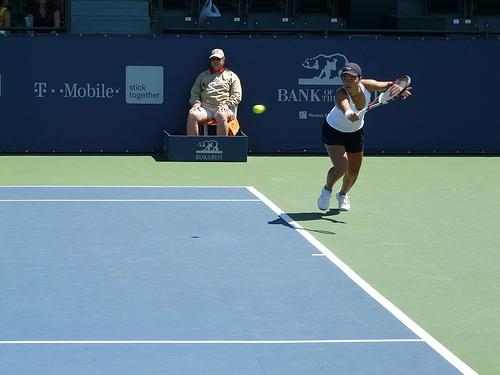Describe the most prominent features of the image in a concise manner. Woman playing tennis wearing a blue hat, white shoes, white top, and black shorts, with distinct shadows on the ground. Write a sentence describing the environment and ambiance of the tennis game shown in the image. The tennis game setting features a well-maintained court, clear blue and green sections, with keen spectators and a man sitting in a judging box. Explain the different court sections and colors in the image. The tennis court features a blue playing area with a white dividing line, and a green out-of-bounds section. Write a sentence describing the scene in the image, focusing on the main character and their action. A female tennis player is striking a green tennis ball in the air while a man observes from a chair on a colorful blue and green court. Provide a description of the individuals featured in the image and their roles. The image shows a woman actively playing tennis, a man sitting and observing the game, and glimpses of two fans sitting in the stands. Give a short description of the image focusing on both players and the court. The image captures the intensity of a tennis game, as a woman skillfully plays with a man intently watching, on a vibrant blue and green tennis court. Describe the action taking place in the image while highlighting the equipment used. A female tennis player, with her racket in hand, skillfully hits a green tennis ball, while her opponent's shadow can be seen on the blue court. Summarize the image focusing on the tennis court and its surroundings. The image features a blue tennis court section with a white dividing line, a green out-of-bounds area, and a blue wall with advertisements. Provide a brief overview of the primary elements in the image. A woman playing tennis, hitting a ball in the air, with a man sitting, watching the game, and a blue tennis court section against a green out-of-bounds area. In one sentence, describe the attire and accessories worn by the woman playing tennis. The female tennis player is wearing a blue hat, white top, black shorts, white tennis shoes, and holding a red, white, and black racket. 